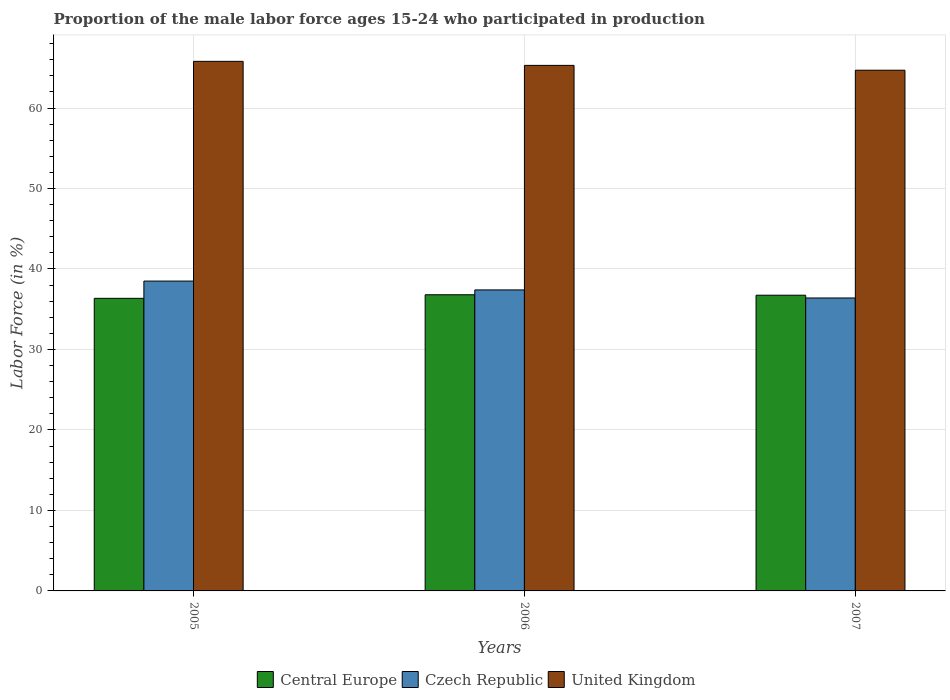How many different coloured bars are there?
Make the answer very short. 3. How many groups of bars are there?
Your response must be concise. 3. How many bars are there on the 1st tick from the right?
Give a very brief answer. 3. What is the label of the 3rd group of bars from the left?
Your response must be concise. 2007. In how many cases, is the number of bars for a given year not equal to the number of legend labels?
Provide a short and direct response. 0. What is the proportion of the male labor force who participated in production in United Kingdom in 2005?
Your answer should be very brief. 65.8. Across all years, what is the maximum proportion of the male labor force who participated in production in Central Europe?
Offer a very short reply. 36.8. Across all years, what is the minimum proportion of the male labor force who participated in production in Central Europe?
Make the answer very short. 36.35. In which year was the proportion of the male labor force who participated in production in Central Europe maximum?
Make the answer very short. 2006. In which year was the proportion of the male labor force who participated in production in Czech Republic minimum?
Provide a short and direct response. 2007. What is the total proportion of the male labor force who participated in production in Central Europe in the graph?
Your answer should be compact. 109.9. What is the difference between the proportion of the male labor force who participated in production in Central Europe in 2006 and that in 2007?
Provide a succinct answer. 0.06. What is the difference between the proportion of the male labor force who participated in production in Central Europe in 2007 and the proportion of the male labor force who participated in production in Czech Republic in 2006?
Make the answer very short. -0.66. What is the average proportion of the male labor force who participated in production in United Kingdom per year?
Provide a short and direct response. 65.27. In the year 2006, what is the difference between the proportion of the male labor force who participated in production in United Kingdom and proportion of the male labor force who participated in production in Czech Republic?
Offer a very short reply. 27.9. In how many years, is the proportion of the male labor force who participated in production in United Kingdom greater than 26 %?
Offer a very short reply. 3. What is the ratio of the proportion of the male labor force who participated in production in Central Europe in 2005 to that in 2006?
Offer a terse response. 0.99. What is the difference between the highest and the second highest proportion of the male labor force who participated in production in Central Europe?
Keep it short and to the point. 0.06. What is the difference between the highest and the lowest proportion of the male labor force who participated in production in Central Europe?
Keep it short and to the point. 0.44. In how many years, is the proportion of the male labor force who participated in production in Czech Republic greater than the average proportion of the male labor force who participated in production in Czech Republic taken over all years?
Ensure brevity in your answer.  1. Is the sum of the proportion of the male labor force who participated in production in Czech Republic in 2005 and 2006 greater than the maximum proportion of the male labor force who participated in production in Central Europe across all years?
Provide a succinct answer. Yes. What does the 2nd bar from the left in 2006 represents?
Keep it short and to the point. Czech Republic. What does the 1st bar from the right in 2006 represents?
Ensure brevity in your answer.  United Kingdom. How many bars are there?
Your answer should be compact. 9. What is the difference between two consecutive major ticks on the Y-axis?
Make the answer very short. 10. Are the values on the major ticks of Y-axis written in scientific E-notation?
Keep it short and to the point. No. Where does the legend appear in the graph?
Your answer should be very brief. Bottom center. What is the title of the graph?
Your response must be concise. Proportion of the male labor force ages 15-24 who participated in production. Does "Lao PDR" appear as one of the legend labels in the graph?
Your answer should be very brief. No. What is the label or title of the X-axis?
Ensure brevity in your answer.  Years. What is the Labor Force (in %) of Central Europe in 2005?
Offer a very short reply. 36.35. What is the Labor Force (in %) in Czech Republic in 2005?
Your answer should be very brief. 38.5. What is the Labor Force (in %) in United Kingdom in 2005?
Keep it short and to the point. 65.8. What is the Labor Force (in %) of Central Europe in 2006?
Make the answer very short. 36.8. What is the Labor Force (in %) in Czech Republic in 2006?
Provide a succinct answer. 37.4. What is the Labor Force (in %) of United Kingdom in 2006?
Provide a short and direct response. 65.3. What is the Labor Force (in %) of Central Europe in 2007?
Keep it short and to the point. 36.74. What is the Labor Force (in %) of Czech Republic in 2007?
Your answer should be very brief. 36.4. What is the Labor Force (in %) in United Kingdom in 2007?
Offer a very short reply. 64.7. Across all years, what is the maximum Labor Force (in %) in Central Europe?
Provide a short and direct response. 36.8. Across all years, what is the maximum Labor Force (in %) of Czech Republic?
Offer a terse response. 38.5. Across all years, what is the maximum Labor Force (in %) of United Kingdom?
Offer a terse response. 65.8. Across all years, what is the minimum Labor Force (in %) in Central Europe?
Give a very brief answer. 36.35. Across all years, what is the minimum Labor Force (in %) of Czech Republic?
Your answer should be very brief. 36.4. Across all years, what is the minimum Labor Force (in %) in United Kingdom?
Your answer should be compact. 64.7. What is the total Labor Force (in %) of Central Europe in the graph?
Provide a short and direct response. 109.9. What is the total Labor Force (in %) in Czech Republic in the graph?
Your response must be concise. 112.3. What is the total Labor Force (in %) of United Kingdom in the graph?
Keep it short and to the point. 195.8. What is the difference between the Labor Force (in %) in Central Europe in 2005 and that in 2006?
Ensure brevity in your answer.  -0.44. What is the difference between the Labor Force (in %) in United Kingdom in 2005 and that in 2006?
Offer a very short reply. 0.5. What is the difference between the Labor Force (in %) of Central Europe in 2005 and that in 2007?
Give a very brief answer. -0.39. What is the difference between the Labor Force (in %) in Czech Republic in 2005 and that in 2007?
Make the answer very short. 2.1. What is the difference between the Labor Force (in %) of Central Europe in 2006 and that in 2007?
Your answer should be very brief. 0.06. What is the difference between the Labor Force (in %) of Czech Republic in 2006 and that in 2007?
Offer a terse response. 1. What is the difference between the Labor Force (in %) of Central Europe in 2005 and the Labor Force (in %) of Czech Republic in 2006?
Offer a very short reply. -1.05. What is the difference between the Labor Force (in %) in Central Europe in 2005 and the Labor Force (in %) in United Kingdom in 2006?
Ensure brevity in your answer.  -28.95. What is the difference between the Labor Force (in %) in Czech Republic in 2005 and the Labor Force (in %) in United Kingdom in 2006?
Your response must be concise. -26.8. What is the difference between the Labor Force (in %) of Central Europe in 2005 and the Labor Force (in %) of Czech Republic in 2007?
Offer a very short reply. -0.05. What is the difference between the Labor Force (in %) in Central Europe in 2005 and the Labor Force (in %) in United Kingdom in 2007?
Ensure brevity in your answer.  -28.35. What is the difference between the Labor Force (in %) of Czech Republic in 2005 and the Labor Force (in %) of United Kingdom in 2007?
Keep it short and to the point. -26.2. What is the difference between the Labor Force (in %) of Central Europe in 2006 and the Labor Force (in %) of Czech Republic in 2007?
Your answer should be very brief. 0.4. What is the difference between the Labor Force (in %) in Central Europe in 2006 and the Labor Force (in %) in United Kingdom in 2007?
Give a very brief answer. -27.9. What is the difference between the Labor Force (in %) of Czech Republic in 2006 and the Labor Force (in %) of United Kingdom in 2007?
Provide a short and direct response. -27.3. What is the average Labor Force (in %) of Central Europe per year?
Provide a short and direct response. 36.63. What is the average Labor Force (in %) of Czech Republic per year?
Offer a terse response. 37.43. What is the average Labor Force (in %) in United Kingdom per year?
Offer a terse response. 65.27. In the year 2005, what is the difference between the Labor Force (in %) in Central Europe and Labor Force (in %) in Czech Republic?
Your answer should be very brief. -2.15. In the year 2005, what is the difference between the Labor Force (in %) of Central Europe and Labor Force (in %) of United Kingdom?
Give a very brief answer. -29.45. In the year 2005, what is the difference between the Labor Force (in %) in Czech Republic and Labor Force (in %) in United Kingdom?
Make the answer very short. -27.3. In the year 2006, what is the difference between the Labor Force (in %) of Central Europe and Labor Force (in %) of Czech Republic?
Offer a terse response. -0.6. In the year 2006, what is the difference between the Labor Force (in %) in Central Europe and Labor Force (in %) in United Kingdom?
Give a very brief answer. -28.5. In the year 2006, what is the difference between the Labor Force (in %) in Czech Republic and Labor Force (in %) in United Kingdom?
Your answer should be compact. -27.9. In the year 2007, what is the difference between the Labor Force (in %) of Central Europe and Labor Force (in %) of Czech Republic?
Provide a short and direct response. 0.34. In the year 2007, what is the difference between the Labor Force (in %) of Central Europe and Labor Force (in %) of United Kingdom?
Offer a very short reply. -27.96. In the year 2007, what is the difference between the Labor Force (in %) of Czech Republic and Labor Force (in %) of United Kingdom?
Ensure brevity in your answer.  -28.3. What is the ratio of the Labor Force (in %) in Central Europe in 2005 to that in 2006?
Ensure brevity in your answer.  0.99. What is the ratio of the Labor Force (in %) in Czech Republic in 2005 to that in 2006?
Offer a very short reply. 1.03. What is the ratio of the Labor Force (in %) of United Kingdom in 2005 to that in 2006?
Your response must be concise. 1.01. What is the ratio of the Labor Force (in %) of Central Europe in 2005 to that in 2007?
Ensure brevity in your answer.  0.99. What is the ratio of the Labor Force (in %) of Czech Republic in 2005 to that in 2007?
Offer a very short reply. 1.06. What is the ratio of the Labor Force (in %) in United Kingdom in 2005 to that in 2007?
Keep it short and to the point. 1.02. What is the ratio of the Labor Force (in %) of Czech Republic in 2006 to that in 2007?
Your answer should be very brief. 1.03. What is the ratio of the Labor Force (in %) in United Kingdom in 2006 to that in 2007?
Offer a very short reply. 1.01. What is the difference between the highest and the second highest Labor Force (in %) in Central Europe?
Give a very brief answer. 0.06. What is the difference between the highest and the second highest Labor Force (in %) of Czech Republic?
Give a very brief answer. 1.1. What is the difference between the highest and the lowest Labor Force (in %) in Central Europe?
Offer a very short reply. 0.44. 